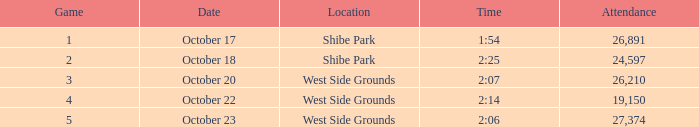During which week was the debut match held that lasted 2:06 and had less than 27,374 people present? None. 